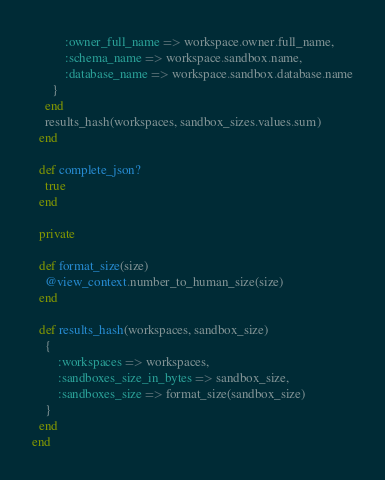<code> <loc_0><loc_0><loc_500><loc_500><_Ruby_>          :owner_full_name => workspace.owner.full_name,
          :schema_name => workspace.sandbox.name,
          :database_name => workspace.sandbox.database.name
      }
    end
    results_hash(workspaces, sandbox_sizes.values.sum)
  end

  def complete_json?
    true
  end

  private

  def format_size(size)
    @view_context.number_to_human_size(size)
  end

  def results_hash(workspaces, sandbox_size)
    {
        :workspaces => workspaces,
        :sandboxes_size_in_bytes => sandbox_size,
        :sandboxes_size => format_size(sandbox_size)
    }
  end
end
</code> 